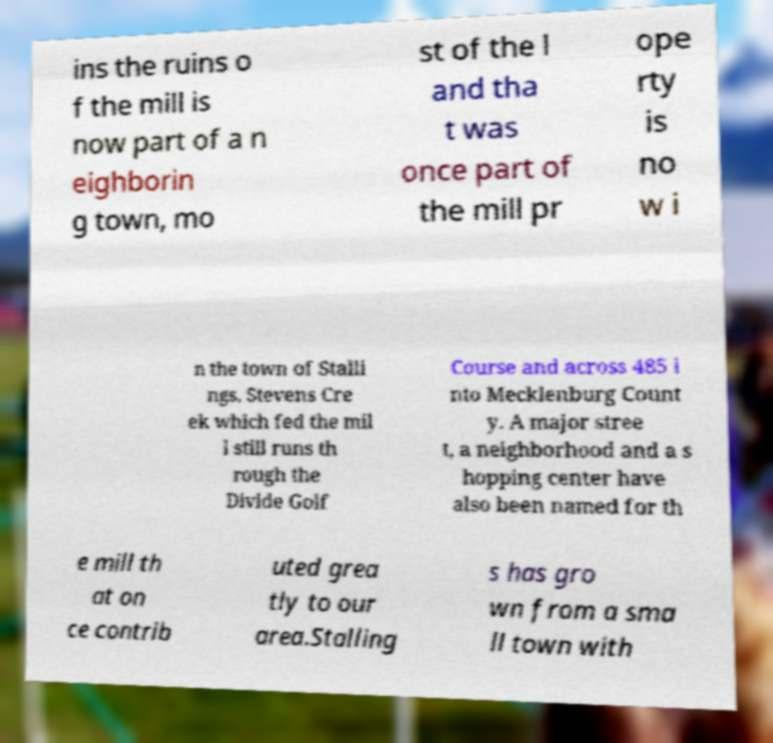I need the written content from this picture converted into text. Can you do that? ins the ruins o f the mill is now part of a n eighborin g town, mo st of the l and tha t was once part of the mill pr ope rty is no w i n the town of Stalli ngs. Stevens Cre ek which fed the mil l still runs th rough the Divide Golf Course and across 485 i nto Mecklenburg Count y. A major stree t, a neighborhood and a s hopping center have also been named for th e mill th at on ce contrib uted grea tly to our area.Stalling s has gro wn from a sma ll town with 